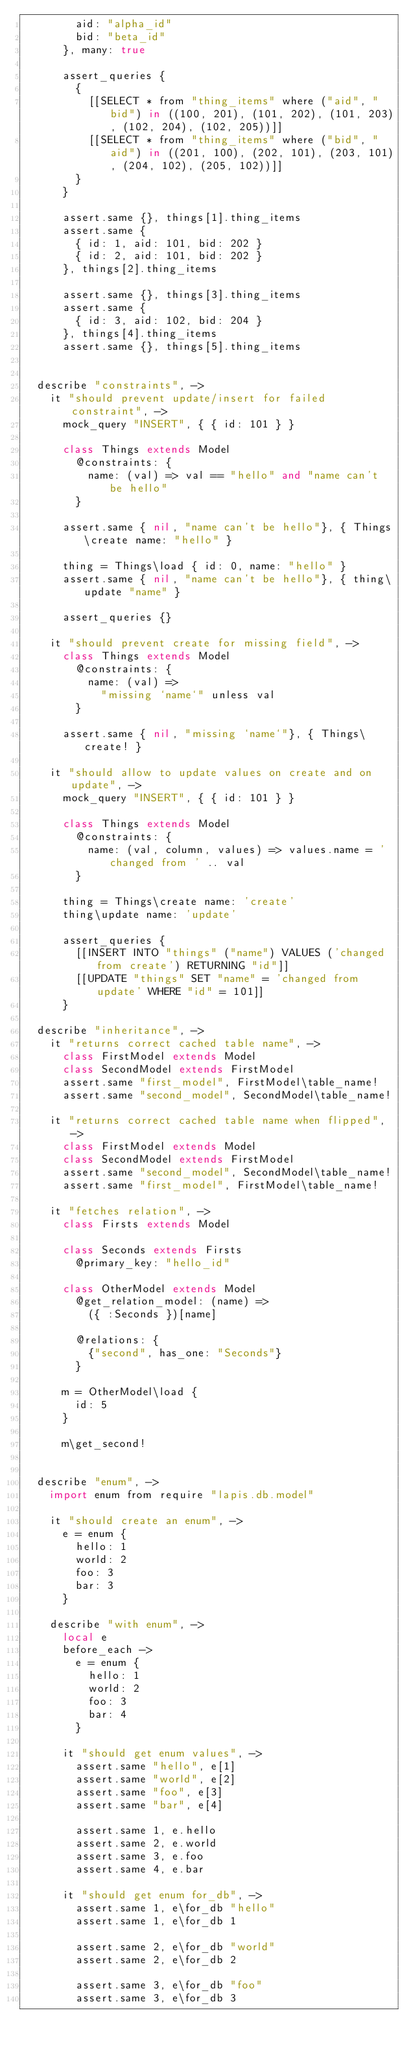Convert code to text. <code><loc_0><loc_0><loc_500><loc_500><_MoonScript_>        aid: "alpha_id"
        bid: "beta_id"
      }, many: true

      assert_queries {
        {
          [[SELECT * from "thing_items" where ("aid", "bid") in ((100, 201), (101, 202), (101, 203), (102, 204), (102, 205))]]
          [[SELECT * from "thing_items" where ("bid", "aid") in ((201, 100), (202, 101), (203, 101), (204, 102), (205, 102))]]
        }
      }

      assert.same {}, things[1].thing_items
      assert.same {
        { id: 1, aid: 101, bid: 202 }
        { id: 2, aid: 101, bid: 202 }
      }, things[2].thing_items

      assert.same {}, things[3].thing_items
      assert.same {
        { id: 3, aid: 102, bid: 204 }
      }, things[4].thing_items
      assert.same {}, things[5].thing_items


  describe "constraints", ->
    it "should prevent update/insert for failed constraint", ->
      mock_query "INSERT", { { id: 101 } }

      class Things extends Model
        @constraints: {
          name: (val) => val == "hello" and "name can't be hello"
        }

      assert.same { nil, "name can't be hello"}, { Things\create name: "hello" }

      thing = Things\load { id: 0, name: "hello" }
      assert.same { nil, "name can't be hello"}, { thing\update "name" }

      assert_queries {}

    it "should prevent create for missing field", ->
      class Things extends Model
        @constraints: {
          name: (val) =>
            "missing `name`" unless val
        }

      assert.same { nil, "missing `name`"}, { Things\create! }

    it "should allow to update values on create and on update", ->
      mock_query "INSERT", { { id: 101 } }

      class Things extends Model
        @constraints: {
          name: (val, column, values) => values.name = 'changed from ' .. val
        }

      thing = Things\create name: 'create'
      thing\update name: 'update'

      assert_queries {
        [[INSERT INTO "things" ("name") VALUES ('changed from create') RETURNING "id"]]
        [[UPDATE "things" SET "name" = 'changed from update' WHERE "id" = 101]]
      }

  describe "inheritance", ->
    it "returns correct cached table name", ->
      class FirstModel extends Model
      class SecondModel extends FirstModel
      assert.same "first_model", FirstModel\table_name!
      assert.same "second_model", SecondModel\table_name!

    it "returns correct cached table name when flipped", ->
      class FirstModel extends Model
      class SecondModel extends FirstModel
      assert.same "second_model", SecondModel\table_name!
      assert.same "first_model", FirstModel\table_name!

    it "fetches relation", ->
      class Firsts extends Model

      class Seconds extends Firsts
        @primary_key: "hello_id"

      class OtherModel extends Model
        @get_relation_model: (name) =>
          ({ :Seconds })[name]

        @relations: {
          {"second", has_one: "Seconds"}
        }

      m = OtherModel\load {
        id: 5
      }

      m\get_second!


  describe "enum", ->
    import enum from require "lapis.db.model"

    it "should create an enum", ->
      e = enum {
        hello: 1
        world: 2
        foo: 3
        bar: 3
      }

    describe "with enum", ->
      local e
      before_each ->
        e = enum {
          hello: 1
          world: 2
          foo: 3
          bar: 4
        }

      it "should get enum values", ->
        assert.same "hello", e[1]
        assert.same "world", e[2]
        assert.same "foo", e[3]
        assert.same "bar", e[4]

        assert.same 1, e.hello
        assert.same 2, e.world
        assert.same 3, e.foo
        assert.same 4, e.bar

      it "should get enum for_db", ->
        assert.same 1, e\for_db "hello"
        assert.same 1, e\for_db 1

        assert.same 2, e\for_db "world"
        assert.same 2, e\for_db 2

        assert.same 3, e\for_db "foo"
        assert.same 3, e\for_db 3
</code> 